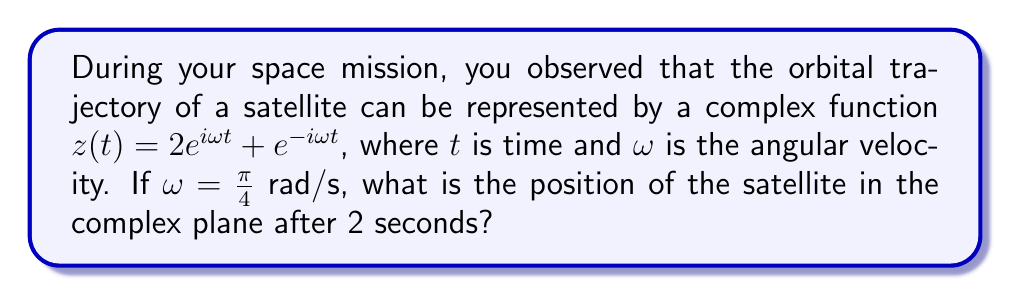Can you solve this math problem? Let's approach this step-by-step:

1) We're given the complex function: $z(t) = 2e^{i\omega t} + e^{-i\omega t}$

2) We know that $\omega = \frac{\pi}{4}$ rad/s and we need to find the position at $t = 2$ seconds.

3) Let's substitute these values into our function:

   $z(2) = 2e^{i(\frac{\pi}{4})(2)} + e^{-i(\frac{\pi}{4})(2)}$

4) Simplify the exponents:

   $z(2) = 2e^{i\frac{\pi}{2}} + e^{-i\frac{\pi}{2}}$

5) Recall Euler's formula: $e^{i\theta} = \cos\theta + i\sin\theta$

6) Apply this to our equation:

   $z(2) = 2(\cos\frac{\pi}{2} + i\sin\frac{\pi}{2}) + (\cos(-\frac{\pi}{2}) + i\sin(-\frac{\pi}{2}))$

7) Simplify, noting that $\cos\frac{\pi}{2} = 0$, $\sin\frac{\pi}{2} = 1$, $\cos(-\frac{\pi}{2}) = 0$, and $\sin(-\frac{\pi}{2}) = -1$:

   $z(2) = 2(0 + i) + (0 - i)$

8) Combine like terms:

   $z(2) = 2i - i = i$

Therefore, after 2 seconds, the satellite's position in the complex plane is $i$.
Answer: $i$ 